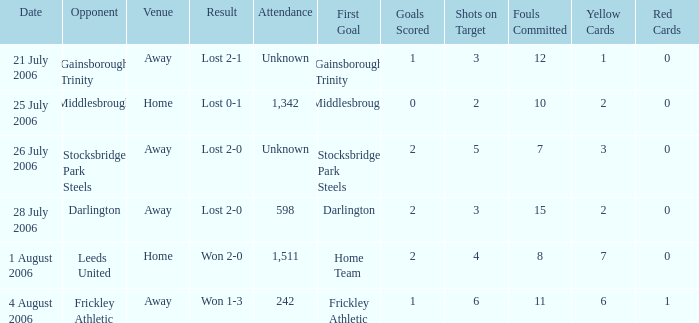What is the result from the Leeds United opponent? Won 2-0. 